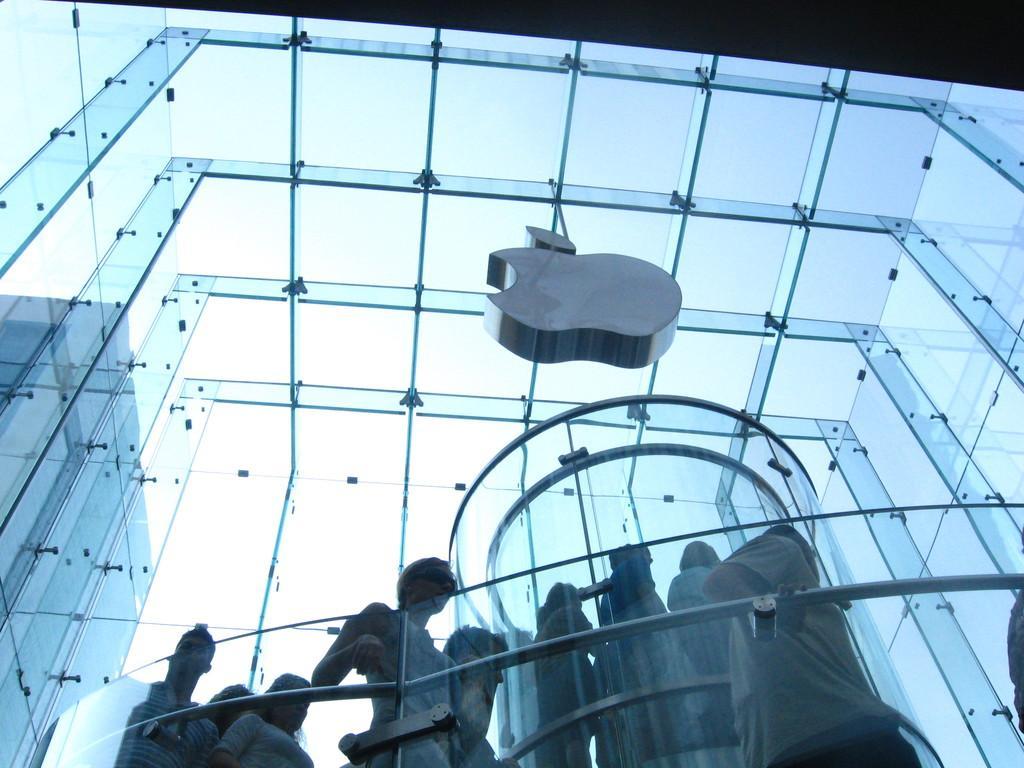Could you give a brief overview of what you see in this image? In this picture I can see glass building from the glass I can see another building on the side and I can see few people standing and I can see blue sky. 